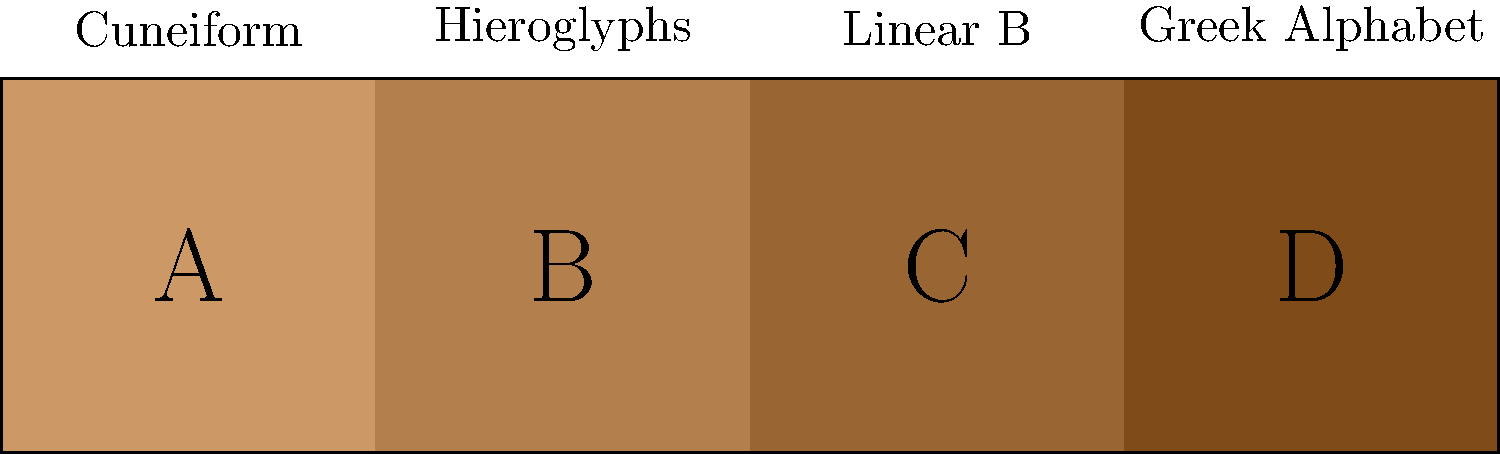Order the following ancient writing systems from oldest to newest based on their historical development: A (Cuneiform), B (Hieroglyphs), C (Linear B), and D (Greek Alphabet). To order these ancient writing systems chronologically, we need to consider their historical development:

1. Cuneiform (A): Developed around 3200 BCE in Mesopotamia, making it the oldest writing system in this group.

2. Hieroglyphs (B): Egyptian hieroglyphs emerged around 3200-3000 BCE, slightly later than Cuneiform but still very ancient.

3. Linear B (C): This script was used for writing Mycenaean Greek, dating back to about 1450-1200 BCE.

4. Greek Alphabet (D): Developed around 800 BCE, evolving from the Phoenician alphabet.

Therefore, the correct chronological order from oldest to newest is:

A (Cuneiform) → B (Hieroglyphs) → C (Linear B) → D (Greek Alphabet)
Answer: A, B, C, D 